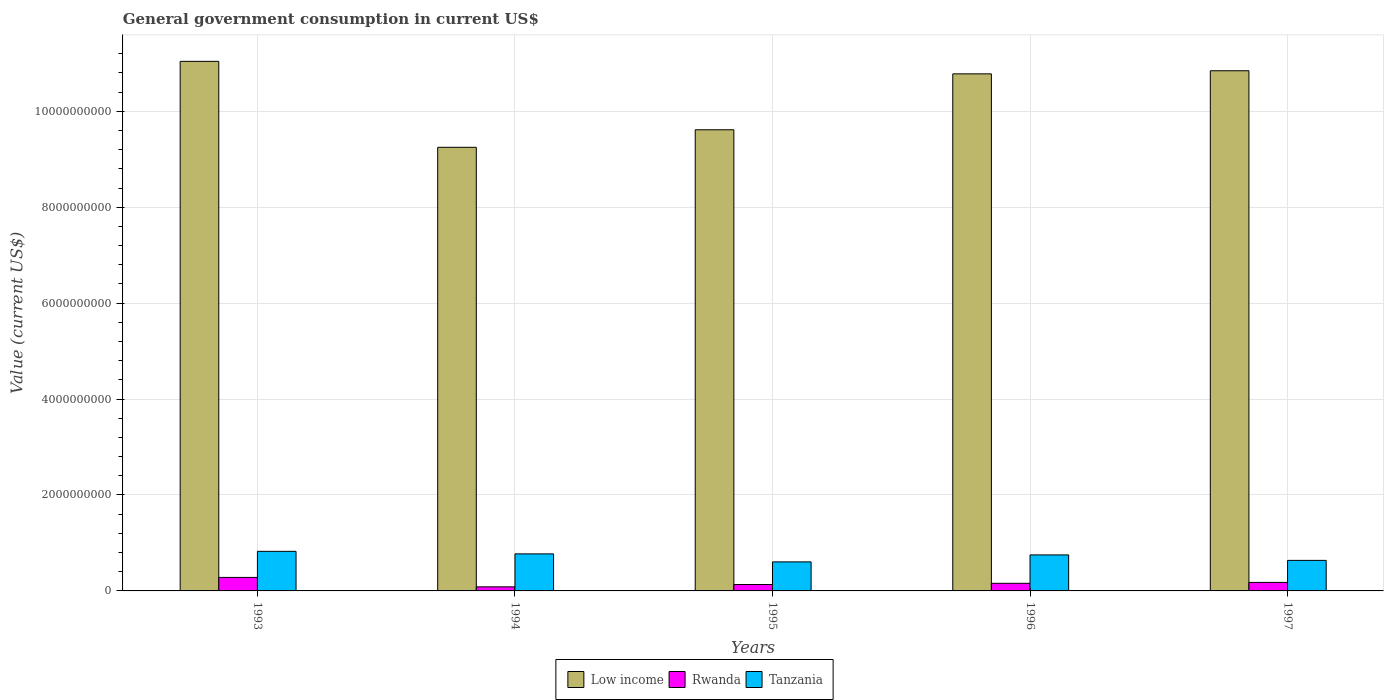Are the number of bars per tick equal to the number of legend labels?
Ensure brevity in your answer.  Yes. Are the number of bars on each tick of the X-axis equal?
Give a very brief answer. Yes. In how many cases, is the number of bars for a given year not equal to the number of legend labels?
Provide a succinct answer. 0. What is the government conusmption in Low income in 1997?
Give a very brief answer. 1.08e+1. Across all years, what is the maximum government conusmption in Tanzania?
Your answer should be compact. 8.25e+08. Across all years, what is the minimum government conusmption in Rwanda?
Provide a succinct answer. 8.47e+07. In which year was the government conusmption in Rwanda maximum?
Your answer should be very brief. 1993. In which year was the government conusmption in Low income minimum?
Make the answer very short. 1994. What is the total government conusmption in Low income in the graph?
Make the answer very short. 5.15e+1. What is the difference between the government conusmption in Tanzania in 1993 and that in 1995?
Your answer should be compact. 2.20e+08. What is the difference between the government conusmption in Rwanda in 1994 and the government conusmption in Tanzania in 1995?
Your answer should be compact. -5.21e+08. What is the average government conusmption in Low income per year?
Give a very brief answer. 1.03e+1. In the year 1996, what is the difference between the government conusmption in Tanzania and government conusmption in Low income?
Your response must be concise. -1.00e+1. In how many years, is the government conusmption in Tanzania greater than 4000000000 US$?
Give a very brief answer. 0. What is the ratio of the government conusmption in Tanzania in 1996 to that in 1997?
Offer a very short reply. 1.18. Is the government conusmption in Rwanda in 1994 less than that in 1995?
Give a very brief answer. Yes. What is the difference between the highest and the second highest government conusmption in Low income?
Your response must be concise. 1.96e+08. What is the difference between the highest and the lowest government conusmption in Tanzania?
Keep it short and to the point. 2.20e+08. In how many years, is the government conusmption in Low income greater than the average government conusmption in Low income taken over all years?
Your answer should be compact. 3. Is the sum of the government conusmption in Low income in 1995 and 1997 greater than the maximum government conusmption in Tanzania across all years?
Provide a succinct answer. Yes. What does the 3rd bar from the left in 1993 represents?
Your response must be concise. Tanzania. What does the 1st bar from the right in 1995 represents?
Your response must be concise. Tanzania. Is it the case that in every year, the sum of the government conusmption in Rwanda and government conusmption in Tanzania is greater than the government conusmption in Low income?
Provide a short and direct response. No. How many bars are there?
Your answer should be very brief. 15. Are all the bars in the graph horizontal?
Offer a very short reply. No. How many years are there in the graph?
Make the answer very short. 5. Does the graph contain any zero values?
Provide a short and direct response. No. Where does the legend appear in the graph?
Make the answer very short. Bottom center. How many legend labels are there?
Your answer should be very brief. 3. How are the legend labels stacked?
Make the answer very short. Horizontal. What is the title of the graph?
Provide a succinct answer. General government consumption in current US$. Does "United States" appear as one of the legend labels in the graph?
Your answer should be compact. No. What is the label or title of the X-axis?
Your answer should be compact. Years. What is the label or title of the Y-axis?
Your answer should be compact. Value (current US$). What is the Value (current US$) of Low income in 1993?
Offer a very short reply. 1.10e+1. What is the Value (current US$) in Rwanda in 1993?
Give a very brief answer. 2.82e+08. What is the Value (current US$) in Tanzania in 1993?
Keep it short and to the point. 8.25e+08. What is the Value (current US$) in Low income in 1994?
Offer a terse response. 9.25e+09. What is the Value (current US$) of Rwanda in 1994?
Provide a succinct answer. 8.47e+07. What is the Value (current US$) in Tanzania in 1994?
Your answer should be very brief. 7.72e+08. What is the Value (current US$) in Low income in 1995?
Offer a terse response. 9.61e+09. What is the Value (current US$) in Rwanda in 1995?
Make the answer very short. 1.33e+08. What is the Value (current US$) of Tanzania in 1995?
Your answer should be compact. 6.06e+08. What is the Value (current US$) of Low income in 1996?
Offer a very short reply. 1.08e+1. What is the Value (current US$) of Rwanda in 1996?
Give a very brief answer. 1.59e+08. What is the Value (current US$) of Tanzania in 1996?
Give a very brief answer. 7.51e+08. What is the Value (current US$) of Low income in 1997?
Give a very brief answer. 1.08e+1. What is the Value (current US$) of Rwanda in 1997?
Make the answer very short. 1.77e+08. What is the Value (current US$) in Tanzania in 1997?
Your response must be concise. 6.37e+08. Across all years, what is the maximum Value (current US$) of Low income?
Your response must be concise. 1.10e+1. Across all years, what is the maximum Value (current US$) in Rwanda?
Offer a terse response. 2.82e+08. Across all years, what is the maximum Value (current US$) in Tanzania?
Your answer should be very brief. 8.25e+08. Across all years, what is the minimum Value (current US$) of Low income?
Give a very brief answer. 9.25e+09. Across all years, what is the minimum Value (current US$) of Rwanda?
Your answer should be very brief. 8.47e+07. Across all years, what is the minimum Value (current US$) of Tanzania?
Keep it short and to the point. 6.06e+08. What is the total Value (current US$) in Low income in the graph?
Offer a very short reply. 5.15e+1. What is the total Value (current US$) in Rwanda in the graph?
Ensure brevity in your answer.  8.36e+08. What is the total Value (current US$) of Tanzania in the graph?
Give a very brief answer. 3.59e+09. What is the difference between the Value (current US$) of Low income in 1993 and that in 1994?
Offer a terse response. 1.79e+09. What is the difference between the Value (current US$) of Rwanda in 1993 and that in 1994?
Offer a terse response. 1.97e+08. What is the difference between the Value (current US$) in Tanzania in 1993 and that in 1994?
Your answer should be very brief. 5.33e+07. What is the difference between the Value (current US$) of Low income in 1993 and that in 1995?
Ensure brevity in your answer.  1.43e+09. What is the difference between the Value (current US$) in Rwanda in 1993 and that in 1995?
Give a very brief answer. 1.48e+08. What is the difference between the Value (current US$) in Tanzania in 1993 and that in 1995?
Provide a succinct answer. 2.20e+08. What is the difference between the Value (current US$) of Low income in 1993 and that in 1996?
Your answer should be very brief. 2.61e+08. What is the difference between the Value (current US$) of Rwanda in 1993 and that in 1996?
Your answer should be very brief. 1.23e+08. What is the difference between the Value (current US$) of Tanzania in 1993 and that in 1996?
Your answer should be very brief. 7.48e+07. What is the difference between the Value (current US$) of Low income in 1993 and that in 1997?
Your answer should be compact. 1.96e+08. What is the difference between the Value (current US$) in Rwanda in 1993 and that in 1997?
Ensure brevity in your answer.  1.04e+08. What is the difference between the Value (current US$) of Tanzania in 1993 and that in 1997?
Offer a terse response. 1.89e+08. What is the difference between the Value (current US$) in Low income in 1994 and that in 1995?
Provide a short and direct response. -3.65e+08. What is the difference between the Value (current US$) of Rwanda in 1994 and that in 1995?
Offer a terse response. -4.87e+07. What is the difference between the Value (current US$) in Tanzania in 1994 and that in 1995?
Your answer should be very brief. 1.67e+08. What is the difference between the Value (current US$) in Low income in 1994 and that in 1996?
Offer a very short reply. -1.53e+09. What is the difference between the Value (current US$) in Rwanda in 1994 and that in 1996?
Ensure brevity in your answer.  -7.41e+07. What is the difference between the Value (current US$) in Tanzania in 1994 and that in 1996?
Keep it short and to the point. 2.15e+07. What is the difference between the Value (current US$) in Low income in 1994 and that in 1997?
Keep it short and to the point. -1.60e+09. What is the difference between the Value (current US$) in Rwanda in 1994 and that in 1997?
Your answer should be very brief. -9.27e+07. What is the difference between the Value (current US$) in Tanzania in 1994 and that in 1997?
Your answer should be very brief. 1.36e+08. What is the difference between the Value (current US$) in Low income in 1995 and that in 1996?
Ensure brevity in your answer.  -1.17e+09. What is the difference between the Value (current US$) in Rwanda in 1995 and that in 1996?
Your answer should be very brief. -2.54e+07. What is the difference between the Value (current US$) in Tanzania in 1995 and that in 1996?
Give a very brief answer. -1.45e+08. What is the difference between the Value (current US$) in Low income in 1995 and that in 1997?
Offer a very short reply. -1.23e+09. What is the difference between the Value (current US$) of Rwanda in 1995 and that in 1997?
Your answer should be compact. -4.40e+07. What is the difference between the Value (current US$) of Tanzania in 1995 and that in 1997?
Provide a short and direct response. -3.10e+07. What is the difference between the Value (current US$) in Low income in 1996 and that in 1997?
Make the answer very short. -6.46e+07. What is the difference between the Value (current US$) of Rwanda in 1996 and that in 1997?
Offer a terse response. -1.86e+07. What is the difference between the Value (current US$) of Tanzania in 1996 and that in 1997?
Provide a succinct answer. 1.14e+08. What is the difference between the Value (current US$) in Low income in 1993 and the Value (current US$) in Rwanda in 1994?
Your answer should be compact. 1.10e+1. What is the difference between the Value (current US$) in Low income in 1993 and the Value (current US$) in Tanzania in 1994?
Offer a terse response. 1.03e+1. What is the difference between the Value (current US$) of Rwanda in 1993 and the Value (current US$) of Tanzania in 1994?
Offer a terse response. -4.90e+08. What is the difference between the Value (current US$) in Low income in 1993 and the Value (current US$) in Rwanda in 1995?
Give a very brief answer. 1.09e+1. What is the difference between the Value (current US$) in Low income in 1993 and the Value (current US$) in Tanzania in 1995?
Your answer should be compact. 1.04e+1. What is the difference between the Value (current US$) of Rwanda in 1993 and the Value (current US$) of Tanzania in 1995?
Your response must be concise. -3.24e+08. What is the difference between the Value (current US$) of Low income in 1993 and the Value (current US$) of Rwanda in 1996?
Give a very brief answer. 1.09e+1. What is the difference between the Value (current US$) of Low income in 1993 and the Value (current US$) of Tanzania in 1996?
Offer a very short reply. 1.03e+1. What is the difference between the Value (current US$) of Rwanda in 1993 and the Value (current US$) of Tanzania in 1996?
Ensure brevity in your answer.  -4.69e+08. What is the difference between the Value (current US$) in Low income in 1993 and the Value (current US$) in Rwanda in 1997?
Provide a short and direct response. 1.09e+1. What is the difference between the Value (current US$) in Low income in 1993 and the Value (current US$) in Tanzania in 1997?
Ensure brevity in your answer.  1.04e+1. What is the difference between the Value (current US$) in Rwanda in 1993 and the Value (current US$) in Tanzania in 1997?
Make the answer very short. -3.55e+08. What is the difference between the Value (current US$) in Low income in 1994 and the Value (current US$) in Rwanda in 1995?
Your response must be concise. 9.12e+09. What is the difference between the Value (current US$) in Low income in 1994 and the Value (current US$) in Tanzania in 1995?
Give a very brief answer. 8.64e+09. What is the difference between the Value (current US$) of Rwanda in 1994 and the Value (current US$) of Tanzania in 1995?
Keep it short and to the point. -5.21e+08. What is the difference between the Value (current US$) in Low income in 1994 and the Value (current US$) in Rwanda in 1996?
Offer a very short reply. 9.09e+09. What is the difference between the Value (current US$) in Low income in 1994 and the Value (current US$) in Tanzania in 1996?
Offer a very short reply. 8.50e+09. What is the difference between the Value (current US$) in Rwanda in 1994 and the Value (current US$) in Tanzania in 1996?
Provide a succinct answer. -6.66e+08. What is the difference between the Value (current US$) of Low income in 1994 and the Value (current US$) of Rwanda in 1997?
Your answer should be very brief. 9.07e+09. What is the difference between the Value (current US$) of Low income in 1994 and the Value (current US$) of Tanzania in 1997?
Ensure brevity in your answer.  8.61e+09. What is the difference between the Value (current US$) of Rwanda in 1994 and the Value (current US$) of Tanzania in 1997?
Offer a terse response. -5.52e+08. What is the difference between the Value (current US$) of Low income in 1995 and the Value (current US$) of Rwanda in 1996?
Give a very brief answer. 9.46e+09. What is the difference between the Value (current US$) in Low income in 1995 and the Value (current US$) in Tanzania in 1996?
Your answer should be compact. 8.86e+09. What is the difference between the Value (current US$) in Rwanda in 1995 and the Value (current US$) in Tanzania in 1996?
Keep it short and to the point. -6.17e+08. What is the difference between the Value (current US$) in Low income in 1995 and the Value (current US$) in Rwanda in 1997?
Offer a terse response. 9.44e+09. What is the difference between the Value (current US$) in Low income in 1995 and the Value (current US$) in Tanzania in 1997?
Give a very brief answer. 8.98e+09. What is the difference between the Value (current US$) of Rwanda in 1995 and the Value (current US$) of Tanzania in 1997?
Give a very brief answer. -5.03e+08. What is the difference between the Value (current US$) in Low income in 1996 and the Value (current US$) in Rwanda in 1997?
Ensure brevity in your answer.  1.06e+1. What is the difference between the Value (current US$) in Low income in 1996 and the Value (current US$) in Tanzania in 1997?
Your answer should be compact. 1.01e+1. What is the difference between the Value (current US$) of Rwanda in 1996 and the Value (current US$) of Tanzania in 1997?
Provide a short and direct response. -4.78e+08. What is the average Value (current US$) in Low income per year?
Offer a very short reply. 1.03e+1. What is the average Value (current US$) in Rwanda per year?
Offer a very short reply. 1.67e+08. What is the average Value (current US$) of Tanzania per year?
Offer a terse response. 7.18e+08. In the year 1993, what is the difference between the Value (current US$) in Low income and Value (current US$) in Rwanda?
Provide a succinct answer. 1.08e+1. In the year 1993, what is the difference between the Value (current US$) of Low income and Value (current US$) of Tanzania?
Provide a short and direct response. 1.02e+1. In the year 1993, what is the difference between the Value (current US$) of Rwanda and Value (current US$) of Tanzania?
Keep it short and to the point. -5.44e+08. In the year 1994, what is the difference between the Value (current US$) of Low income and Value (current US$) of Rwanda?
Provide a succinct answer. 9.16e+09. In the year 1994, what is the difference between the Value (current US$) in Low income and Value (current US$) in Tanzania?
Ensure brevity in your answer.  8.48e+09. In the year 1994, what is the difference between the Value (current US$) of Rwanda and Value (current US$) of Tanzania?
Your response must be concise. -6.87e+08. In the year 1995, what is the difference between the Value (current US$) of Low income and Value (current US$) of Rwanda?
Keep it short and to the point. 9.48e+09. In the year 1995, what is the difference between the Value (current US$) of Low income and Value (current US$) of Tanzania?
Make the answer very short. 9.01e+09. In the year 1995, what is the difference between the Value (current US$) of Rwanda and Value (current US$) of Tanzania?
Your answer should be compact. -4.72e+08. In the year 1996, what is the difference between the Value (current US$) in Low income and Value (current US$) in Rwanda?
Your answer should be compact. 1.06e+1. In the year 1996, what is the difference between the Value (current US$) of Low income and Value (current US$) of Tanzania?
Your answer should be compact. 1.00e+1. In the year 1996, what is the difference between the Value (current US$) of Rwanda and Value (current US$) of Tanzania?
Provide a short and direct response. -5.92e+08. In the year 1997, what is the difference between the Value (current US$) in Low income and Value (current US$) in Rwanda?
Ensure brevity in your answer.  1.07e+1. In the year 1997, what is the difference between the Value (current US$) in Low income and Value (current US$) in Tanzania?
Offer a terse response. 1.02e+1. In the year 1997, what is the difference between the Value (current US$) in Rwanda and Value (current US$) in Tanzania?
Offer a terse response. -4.59e+08. What is the ratio of the Value (current US$) in Low income in 1993 to that in 1994?
Keep it short and to the point. 1.19. What is the ratio of the Value (current US$) in Rwanda in 1993 to that in 1994?
Provide a short and direct response. 3.33. What is the ratio of the Value (current US$) of Tanzania in 1993 to that in 1994?
Give a very brief answer. 1.07. What is the ratio of the Value (current US$) of Low income in 1993 to that in 1995?
Provide a succinct answer. 1.15. What is the ratio of the Value (current US$) of Rwanda in 1993 to that in 1995?
Make the answer very short. 2.11. What is the ratio of the Value (current US$) of Tanzania in 1993 to that in 1995?
Provide a short and direct response. 1.36. What is the ratio of the Value (current US$) in Low income in 1993 to that in 1996?
Offer a terse response. 1.02. What is the ratio of the Value (current US$) in Rwanda in 1993 to that in 1996?
Provide a short and direct response. 1.77. What is the ratio of the Value (current US$) of Tanzania in 1993 to that in 1996?
Offer a very short reply. 1.1. What is the ratio of the Value (current US$) of Low income in 1993 to that in 1997?
Your answer should be very brief. 1.02. What is the ratio of the Value (current US$) of Rwanda in 1993 to that in 1997?
Provide a short and direct response. 1.59. What is the ratio of the Value (current US$) of Tanzania in 1993 to that in 1997?
Your answer should be compact. 1.3. What is the ratio of the Value (current US$) in Rwanda in 1994 to that in 1995?
Your response must be concise. 0.64. What is the ratio of the Value (current US$) in Tanzania in 1994 to that in 1995?
Offer a terse response. 1.28. What is the ratio of the Value (current US$) of Low income in 1994 to that in 1996?
Your response must be concise. 0.86. What is the ratio of the Value (current US$) in Rwanda in 1994 to that in 1996?
Provide a short and direct response. 0.53. What is the ratio of the Value (current US$) in Tanzania in 1994 to that in 1996?
Ensure brevity in your answer.  1.03. What is the ratio of the Value (current US$) in Low income in 1994 to that in 1997?
Offer a terse response. 0.85. What is the ratio of the Value (current US$) of Rwanda in 1994 to that in 1997?
Provide a succinct answer. 0.48. What is the ratio of the Value (current US$) in Tanzania in 1994 to that in 1997?
Provide a short and direct response. 1.21. What is the ratio of the Value (current US$) of Low income in 1995 to that in 1996?
Offer a very short reply. 0.89. What is the ratio of the Value (current US$) of Rwanda in 1995 to that in 1996?
Offer a very short reply. 0.84. What is the ratio of the Value (current US$) of Tanzania in 1995 to that in 1996?
Make the answer very short. 0.81. What is the ratio of the Value (current US$) in Low income in 1995 to that in 1997?
Ensure brevity in your answer.  0.89. What is the ratio of the Value (current US$) of Rwanda in 1995 to that in 1997?
Give a very brief answer. 0.75. What is the ratio of the Value (current US$) of Tanzania in 1995 to that in 1997?
Your answer should be compact. 0.95. What is the ratio of the Value (current US$) of Rwanda in 1996 to that in 1997?
Provide a succinct answer. 0.9. What is the ratio of the Value (current US$) of Tanzania in 1996 to that in 1997?
Your answer should be compact. 1.18. What is the difference between the highest and the second highest Value (current US$) in Low income?
Offer a terse response. 1.96e+08. What is the difference between the highest and the second highest Value (current US$) in Rwanda?
Give a very brief answer. 1.04e+08. What is the difference between the highest and the second highest Value (current US$) of Tanzania?
Your answer should be very brief. 5.33e+07. What is the difference between the highest and the lowest Value (current US$) of Low income?
Offer a terse response. 1.79e+09. What is the difference between the highest and the lowest Value (current US$) in Rwanda?
Your answer should be very brief. 1.97e+08. What is the difference between the highest and the lowest Value (current US$) of Tanzania?
Give a very brief answer. 2.20e+08. 